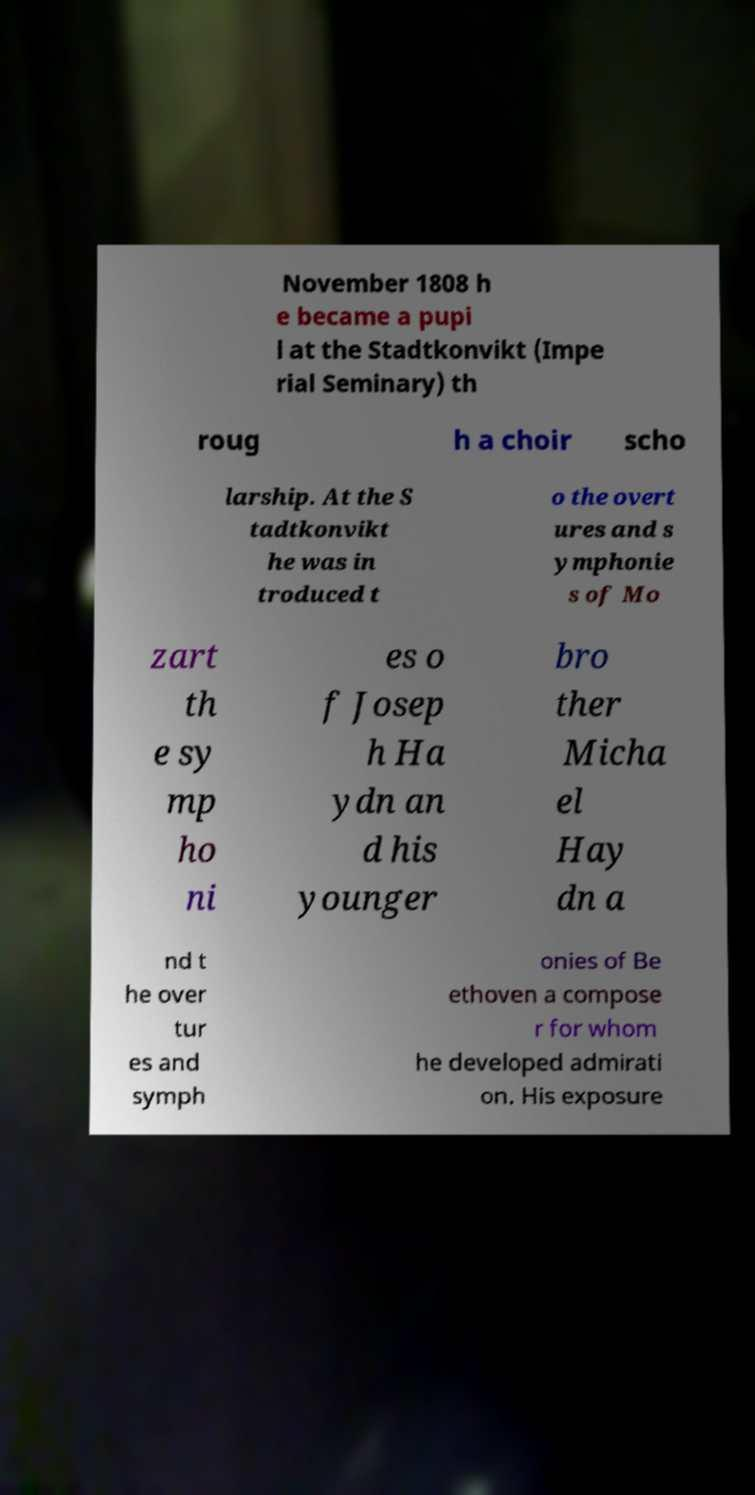Please identify and transcribe the text found in this image. November 1808 h e became a pupi l at the Stadtkonvikt (Impe rial Seminary) th roug h a choir scho larship. At the S tadtkonvikt he was in troduced t o the overt ures and s ymphonie s of Mo zart th e sy mp ho ni es o f Josep h Ha ydn an d his younger bro ther Micha el Hay dn a nd t he over tur es and symph onies of Be ethoven a compose r for whom he developed admirati on. His exposure 